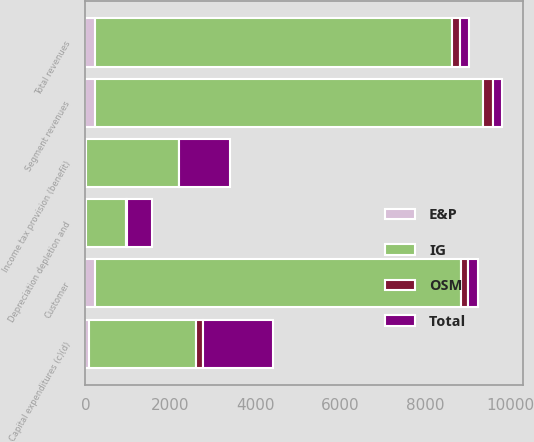<chart> <loc_0><loc_0><loc_500><loc_500><stacked_bar_chart><ecel><fcel>Customer<fcel>Segment revenues<fcel>Total revenues<fcel>Depreciation depletion and<fcel>Income tax provision (benefit)<fcel>Capital expenditures (c)(d)<nl><fcel>IG<fcel>8623<fcel>9155<fcel>8426<fcel>963<fcel>2172<fcel>2511<nl><fcel>OSM<fcel>181<fcel>221<fcel>181<fcel>22<fcel>21<fcel>165<nl><fcel>Total<fcel>218<fcel>218<fcel>218<fcel>587<fcel>1183<fcel>1640<nl><fcel>E&P<fcel>218<fcel>218<fcel>218<fcel>6<fcel>24<fcel>93<nl></chart> 